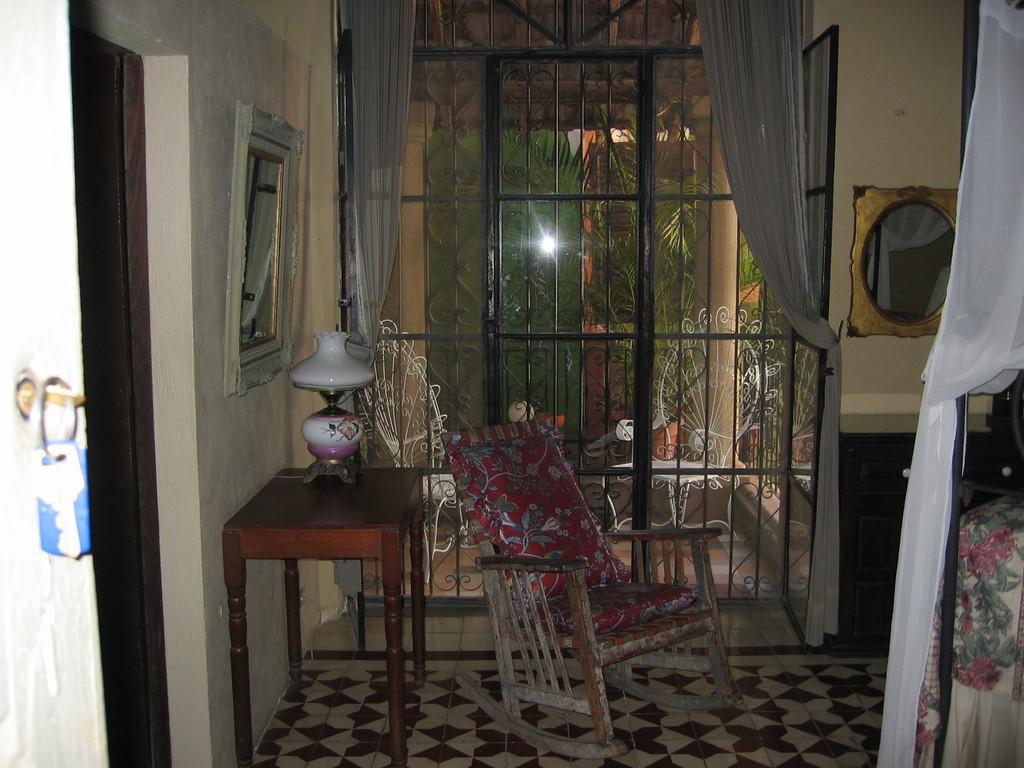How would you summarize this image in a sentence or two? In this image we can see keys, wooden table on which we can see a lamp, chairs, bed, mirrors on the wall, curtains, windows through which we can see trees and pillars in the background. 